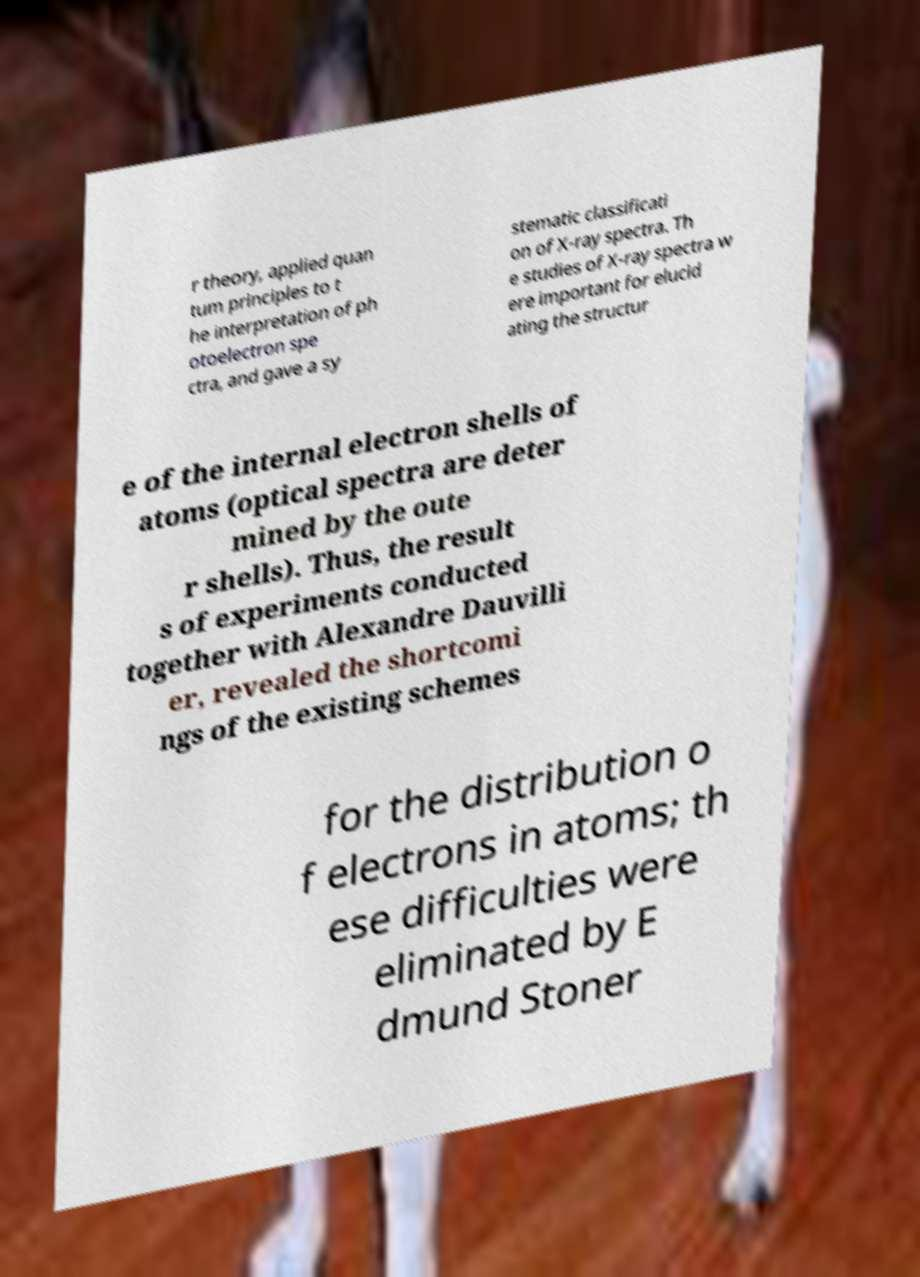Can you read and provide the text displayed in the image?This photo seems to have some interesting text. Can you extract and type it out for me? r theory, applied quan tum principles to t he interpretation of ph otoelectron spe ctra, and gave a sy stematic classificati on of X-ray spectra. Th e studies of X-ray spectra w ere important for elucid ating the structur e of the internal electron shells of atoms (optical spectra are deter mined by the oute r shells). Thus, the result s of experiments conducted together with Alexandre Dauvilli er, revealed the shortcomi ngs of the existing schemes for the distribution o f electrons in atoms; th ese difficulties were eliminated by E dmund Stoner 